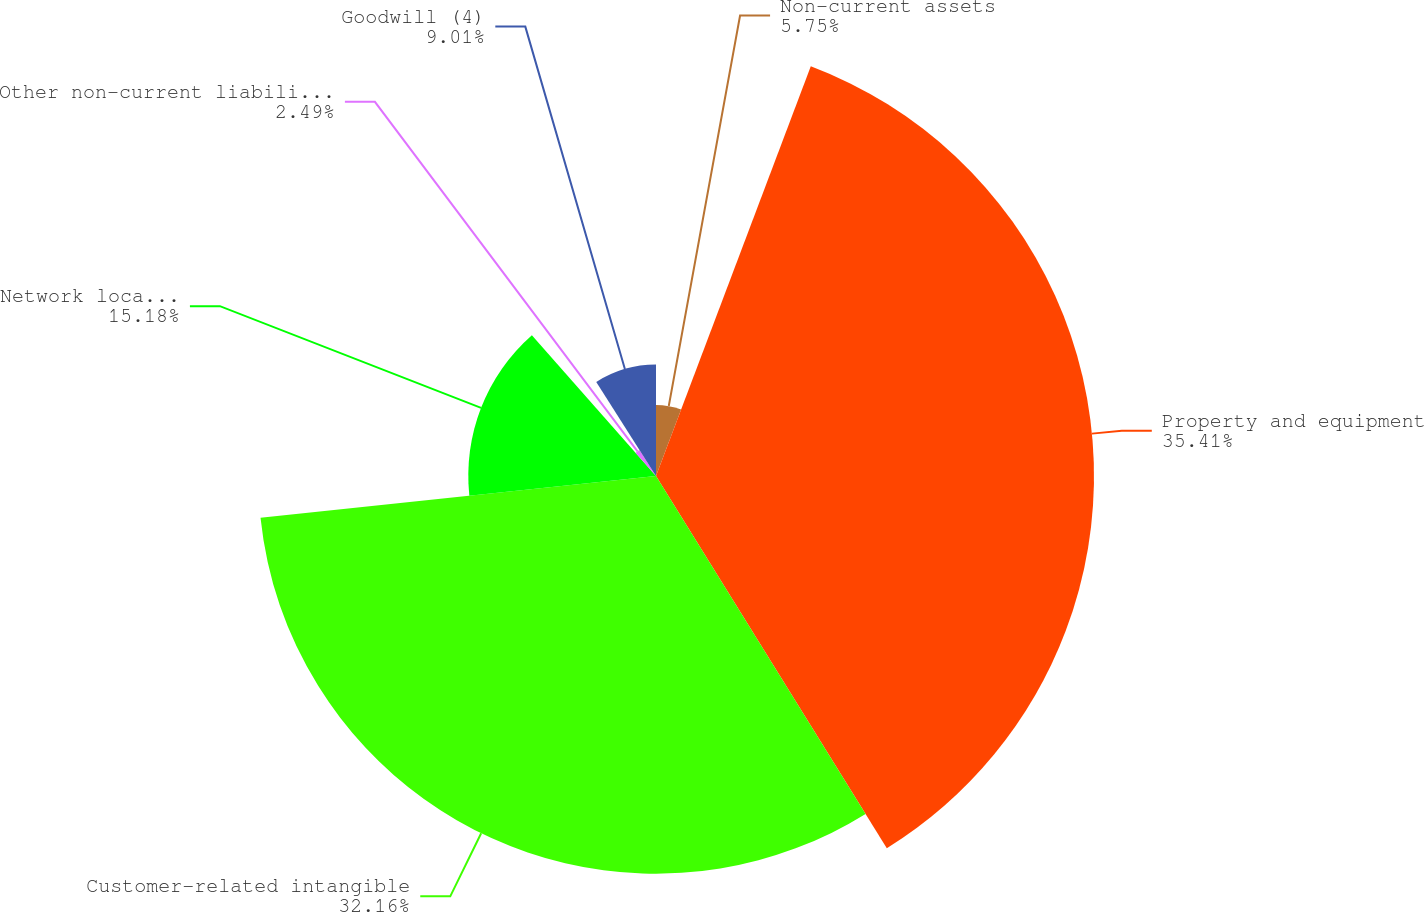<chart> <loc_0><loc_0><loc_500><loc_500><pie_chart><fcel>Non-current assets<fcel>Property and equipment<fcel>Customer-related intangible<fcel>Network location intangible<fcel>Other non-current liabilities<fcel>Goodwill (4)<nl><fcel>5.75%<fcel>35.42%<fcel>32.16%<fcel>15.18%<fcel>2.49%<fcel>9.01%<nl></chart> 